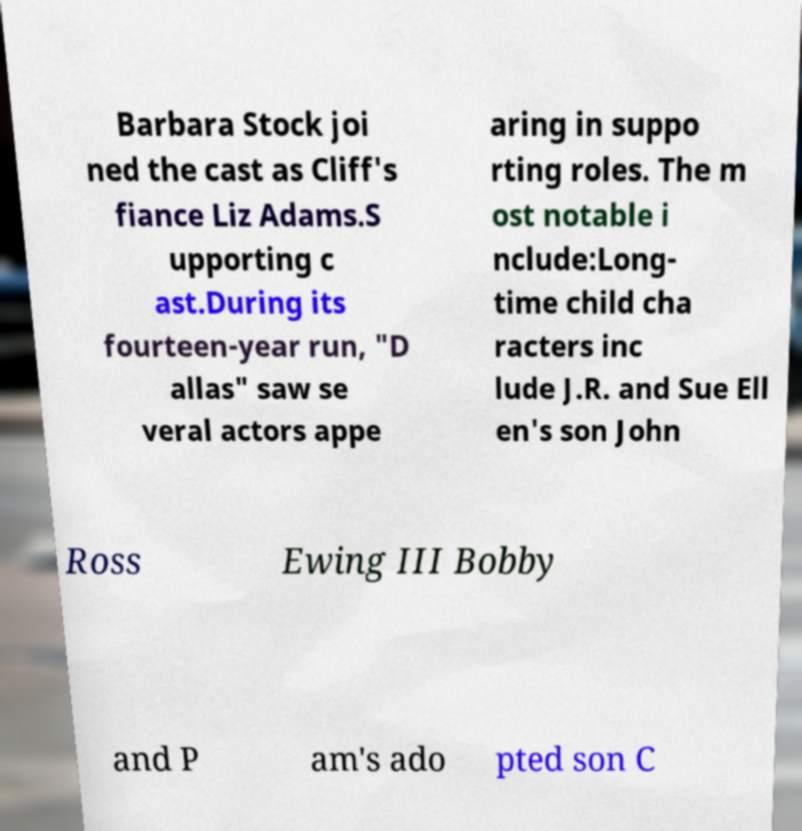Can you accurately transcribe the text from the provided image for me? Barbara Stock joi ned the cast as Cliff's fiance Liz Adams.S upporting c ast.During its fourteen-year run, "D allas" saw se veral actors appe aring in suppo rting roles. The m ost notable i nclude:Long- time child cha racters inc lude J.R. and Sue Ell en's son John Ross Ewing III Bobby and P am's ado pted son C 